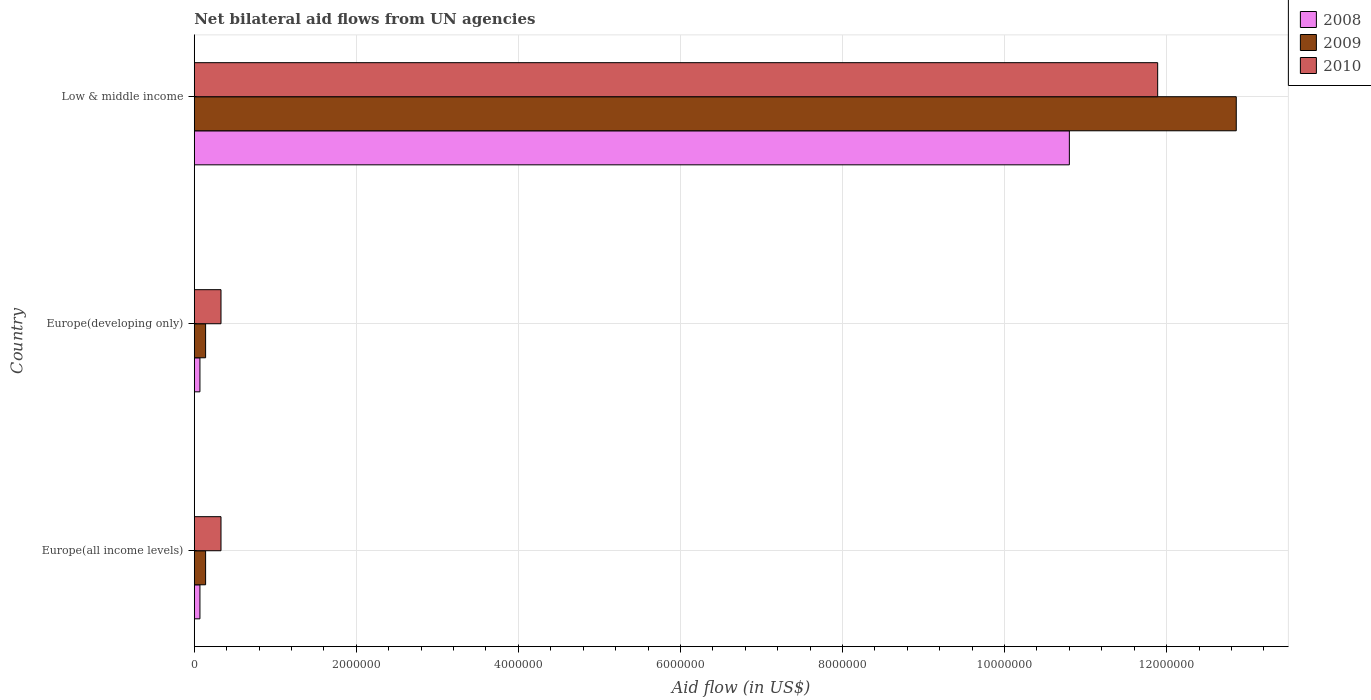How many different coloured bars are there?
Make the answer very short. 3. How many groups of bars are there?
Make the answer very short. 3. Are the number of bars per tick equal to the number of legend labels?
Provide a short and direct response. Yes. Are the number of bars on each tick of the Y-axis equal?
Your answer should be compact. Yes. How many bars are there on the 2nd tick from the top?
Ensure brevity in your answer.  3. How many bars are there on the 3rd tick from the bottom?
Give a very brief answer. 3. What is the label of the 2nd group of bars from the top?
Ensure brevity in your answer.  Europe(developing only). In how many cases, is the number of bars for a given country not equal to the number of legend labels?
Offer a terse response. 0. Across all countries, what is the maximum net bilateral aid flow in 2010?
Provide a short and direct response. 1.19e+07. Across all countries, what is the minimum net bilateral aid flow in 2009?
Your answer should be very brief. 1.40e+05. In which country was the net bilateral aid flow in 2010 maximum?
Provide a succinct answer. Low & middle income. In which country was the net bilateral aid flow in 2010 minimum?
Your answer should be very brief. Europe(all income levels). What is the total net bilateral aid flow in 2010 in the graph?
Make the answer very short. 1.26e+07. What is the average net bilateral aid flow in 2010 per country?
Your response must be concise. 4.18e+06. What is the difference between the net bilateral aid flow in 2008 and net bilateral aid flow in 2010 in Low & middle income?
Ensure brevity in your answer.  -1.09e+06. What is the ratio of the net bilateral aid flow in 2009 in Europe(developing only) to that in Low & middle income?
Ensure brevity in your answer.  0.01. Is the net bilateral aid flow in 2010 in Europe(developing only) less than that in Low & middle income?
Your response must be concise. Yes. What is the difference between the highest and the second highest net bilateral aid flow in 2008?
Provide a succinct answer. 1.07e+07. What is the difference between the highest and the lowest net bilateral aid flow in 2008?
Your answer should be very brief. 1.07e+07. Is the sum of the net bilateral aid flow in 2010 in Europe(all income levels) and Europe(developing only) greater than the maximum net bilateral aid flow in 2008 across all countries?
Ensure brevity in your answer.  No. What does the 1st bar from the top in Europe(all income levels) represents?
Ensure brevity in your answer.  2010. What does the 2nd bar from the bottom in Europe(all income levels) represents?
Keep it short and to the point. 2009. Are all the bars in the graph horizontal?
Give a very brief answer. Yes. How many countries are there in the graph?
Offer a terse response. 3. Does the graph contain any zero values?
Provide a succinct answer. No. Does the graph contain grids?
Give a very brief answer. Yes. How many legend labels are there?
Your answer should be compact. 3. What is the title of the graph?
Give a very brief answer. Net bilateral aid flows from UN agencies. Does "1999" appear as one of the legend labels in the graph?
Ensure brevity in your answer.  No. What is the label or title of the X-axis?
Provide a short and direct response. Aid flow (in US$). What is the Aid flow (in US$) of 2008 in Europe(all income levels)?
Offer a very short reply. 7.00e+04. What is the Aid flow (in US$) of 2009 in Europe(all income levels)?
Provide a succinct answer. 1.40e+05. What is the Aid flow (in US$) in 2008 in Low & middle income?
Your answer should be compact. 1.08e+07. What is the Aid flow (in US$) of 2009 in Low & middle income?
Give a very brief answer. 1.29e+07. What is the Aid flow (in US$) in 2010 in Low & middle income?
Offer a very short reply. 1.19e+07. Across all countries, what is the maximum Aid flow (in US$) in 2008?
Your answer should be compact. 1.08e+07. Across all countries, what is the maximum Aid flow (in US$) in 2009?
Ensure brevity in your answer.  1.29e+07. Across all countries, what is the maximum Aid flow (in US$) of 2010?
Keep it short and to the point. 1.19e+07. Across all countries, what is the minimum Aid flow (in US$) in 2008?
Keep it short and to the point. 7.00e+04. Across all countries, what is the minimum Aid flow (in US$) of 2009?
Ensure brevity in your answer.  1.40e+05. Across all countries, what is the minimum Aid flow (in US$) in 2010?
Offer a terse response. 3.30e+05. What is the total Aid flow (in US$) in 2008 in the graph?
Make the answer very short. 1.09e+07. What is the total Aid flow (in US$) of 2009 in the graph?
Provide a short and direct response. 1.31e+07. What is the total Aid flow (in US$) of 2010 in the graph?
Provide a succinct answer. 1.26e+07. What is the difference between the Aid flow (in US$) of 2008 in Europe(all income levels) and that in Europe(developing only)?
Make the answer very short. 0. What is the difference between the Aid flow (in US$) in 2009 in Europe(all income levels) and that in Europe(developing only)?
Your response must be concise. 0. What is the difference between the Aid flow (in US$) of 2008 in Europe(all income levels) and that in Low & middle income?
Provide a succinct answer. -1.07e+07. What is the difference between the Aid flow (in US$) in 2009 in Europe(all income levels) and that in Low & middle income?
Offer a very short reply. -1.27e+07. What is the difference between the Aid flow (in US$) of 2010 in Europe(all income levels) and that in Low & middle income?
Make the answer very short. -1.16e+07. What is the difference between the Aid flow (in US$) of 2008 in Europe(developing only) and that in Low & middle income?
Your response must be concise. -1.07e+07. What is the difference between the Aid flow (in US$) of 2009 in Europe(developing only) and that in Low & middle income?
Your response must be concise. -1.27e+07. What is the difference between the Aid flow (in US$) in 2010 in Europe(developing only) and that in Low & middle income?
Offer a terse response. -1.16e+07. What is the difference between the Aid flow (in US$) of 2008 in Europe(all income levels) and the Aid flow (in US$) of 2009 in Europe(developing only)?
Your answer should be very brief. -7.00e+04. What is the difference between the Aid flow (in US$) in 2008 in Europe(all income levels) and the Aid flow (in US$) in 2009 in Low & middle income?
Make the answer very short. -1.28e+07. What is the difference between the Aid flow (in US$) in 2008 in Europe(all income levels) and the Aid flow (in US$) in 2010 in Low & middle income?
Your answer should be very brief. -1.18e+07. What is the difference between the Aid flow (in US$) of 2009 in Europe(all income levels) and the Aid flow (in US$) of 2010 in Low & middle income?
Provide a succinct answer. -1.18e+07. What is the difference between the Aid flow (in US$) of 2008 in Europe(developing only) and the Aid flow (in US$) of 2009 in Low & middle income?
Make the answer very short. -1.28e+07. What is the difference between the Aid flow (in US$) in 2008 in Europe(developing only) and the Aid flow (in US$) in 2010 in Low & middle income?
Offer a terse response. -1.18e+07. What is the difference between the Aid flow (in US$) of 2009 in Europe(developing only) and the Aid flow (in US$) of 2010 in Low & middle income?
Keep it short and to the point. -1.18e+07. What is the average Aid flow (in US$) of 2008 per country?
Offer a very short reply. 3.65e+06. What is the average Aid flow (in US$) in 2009 per country?
Offer a very short reply. 4.38e+06. What is the average Aid flow (in US$) of 2010 per country?
Keep it short and to the point. 4.18e+06. What is the difference between the Aid flow (in US$) in 2008 and Aid flow (in US$) in 2009 in Europe(all income levels)?
Offer a terse response. -7.00e+04. What is the difference between the Aid flow (in US$) in 2008 and Aid flow (in US$) in 2010 in Europe(all income levels)?
Make the answer very short. -2.60e+05. What is the difference between the Aid flow (in US$) of 2008 and Aid flow (in US$) of 2009 in Europe(developing only)?
Your response must be concise. -7.00e+04. What is the difference between the Aid flow (in US$) of 2008 and Aid flow (in US$) of 2010 in Europe(developing only)?
Provide a short and direct response. -2.60e+05. What is the difference between the Aid flow (in US$) of 2009 and Aid flow (in US$) of 2010 in Europe(developing only)?
Make the answer very short. -1.90e+05. What is the difference between the Aid flow (in US$) of 2008 and Aid flow (in US$) of 2009 in Low & middle income?
Your answer should be compact. -2.06e+06. What is the difference between the Aid flow (in US$) of 2008 and Aid flow (in US$) of 2010 in Low & middle income?
Provide a succinct answer. -1.09e+06. What is the difference between the Aid flow (in US$) in 2009 and Aid flow (in US$) in 2010 in Low & middle income?
Offer a very short reply. 9.70e+05. What is the ratio of the Aid flow (in US$) in 2008 in Europe(all income levels) to that in Europe(developing only)?
Your answer should be compact. 1. What is the ratio of the Aid flow (in US$) in 2009 in Europe(all income levels) to that in Europe(developing only)?
Offer a terse response. 1. What is the ratio of the Aid flow (in US$) of 2010 in Europe(all income levels) to that in Europe(developing only)?
Provide a short and direct response. 1. What is the ratio of the Aid flow (in US$) of 2008 in Europe(all income levels) to that in Low & middle income?
Offer a terse response. 0.01. What is the ratio of the Aid flow (in US$) of 2009 in Europe(all income levels) to that in Low & middle income?
Ensure brevity in your answer.  0.01. What is the ratio of the Aid flow (in US$) of 2010 in Europe(all income levels) to that in Low & middle income?
Offer a terse response. 0.03. What is the ratio of the Aid flow (in US$) of 2008 in Europe(developing only) to that in Low & middle income?
Keep it short and to the point. 0.01. What is the ratio of the Aid flow (in US$) in 2009 in Europe(developing only) to that in Low & middle income?
Offer a very short reply. 0.01. What is the ratio of the Aid flow (in US$) of 2010 in Europe(developing only) to that in Low & middle income?
Give a very brief answer. 0.03. What is the difference between the highest and the second highest Aid flow (in US$) of 2008?
Make the answer very short. 1.07e+07. What is the difference between the highest and the second highest Aid flow (in US$) in 2009?
Your answer should be very brief. 1.27e+07. What is the difference between the highest and the second highest Aid flow (in US$) in 2010?
Your answer should be compact. 1.16e+07. What is the difference between the highest and the lowest Aid flow (in US$) of 2008?
Ensure brevity in your answer.  1.07e+07. What is the difference between the highest and the lowest Aid flow (in US$) in 2009?
Offer a very short reply. 1.27e+07. What is the difference between the highest and the lowest Aid flow (in US$) of 2010?
Make the answer very short. 1.16e+07. 